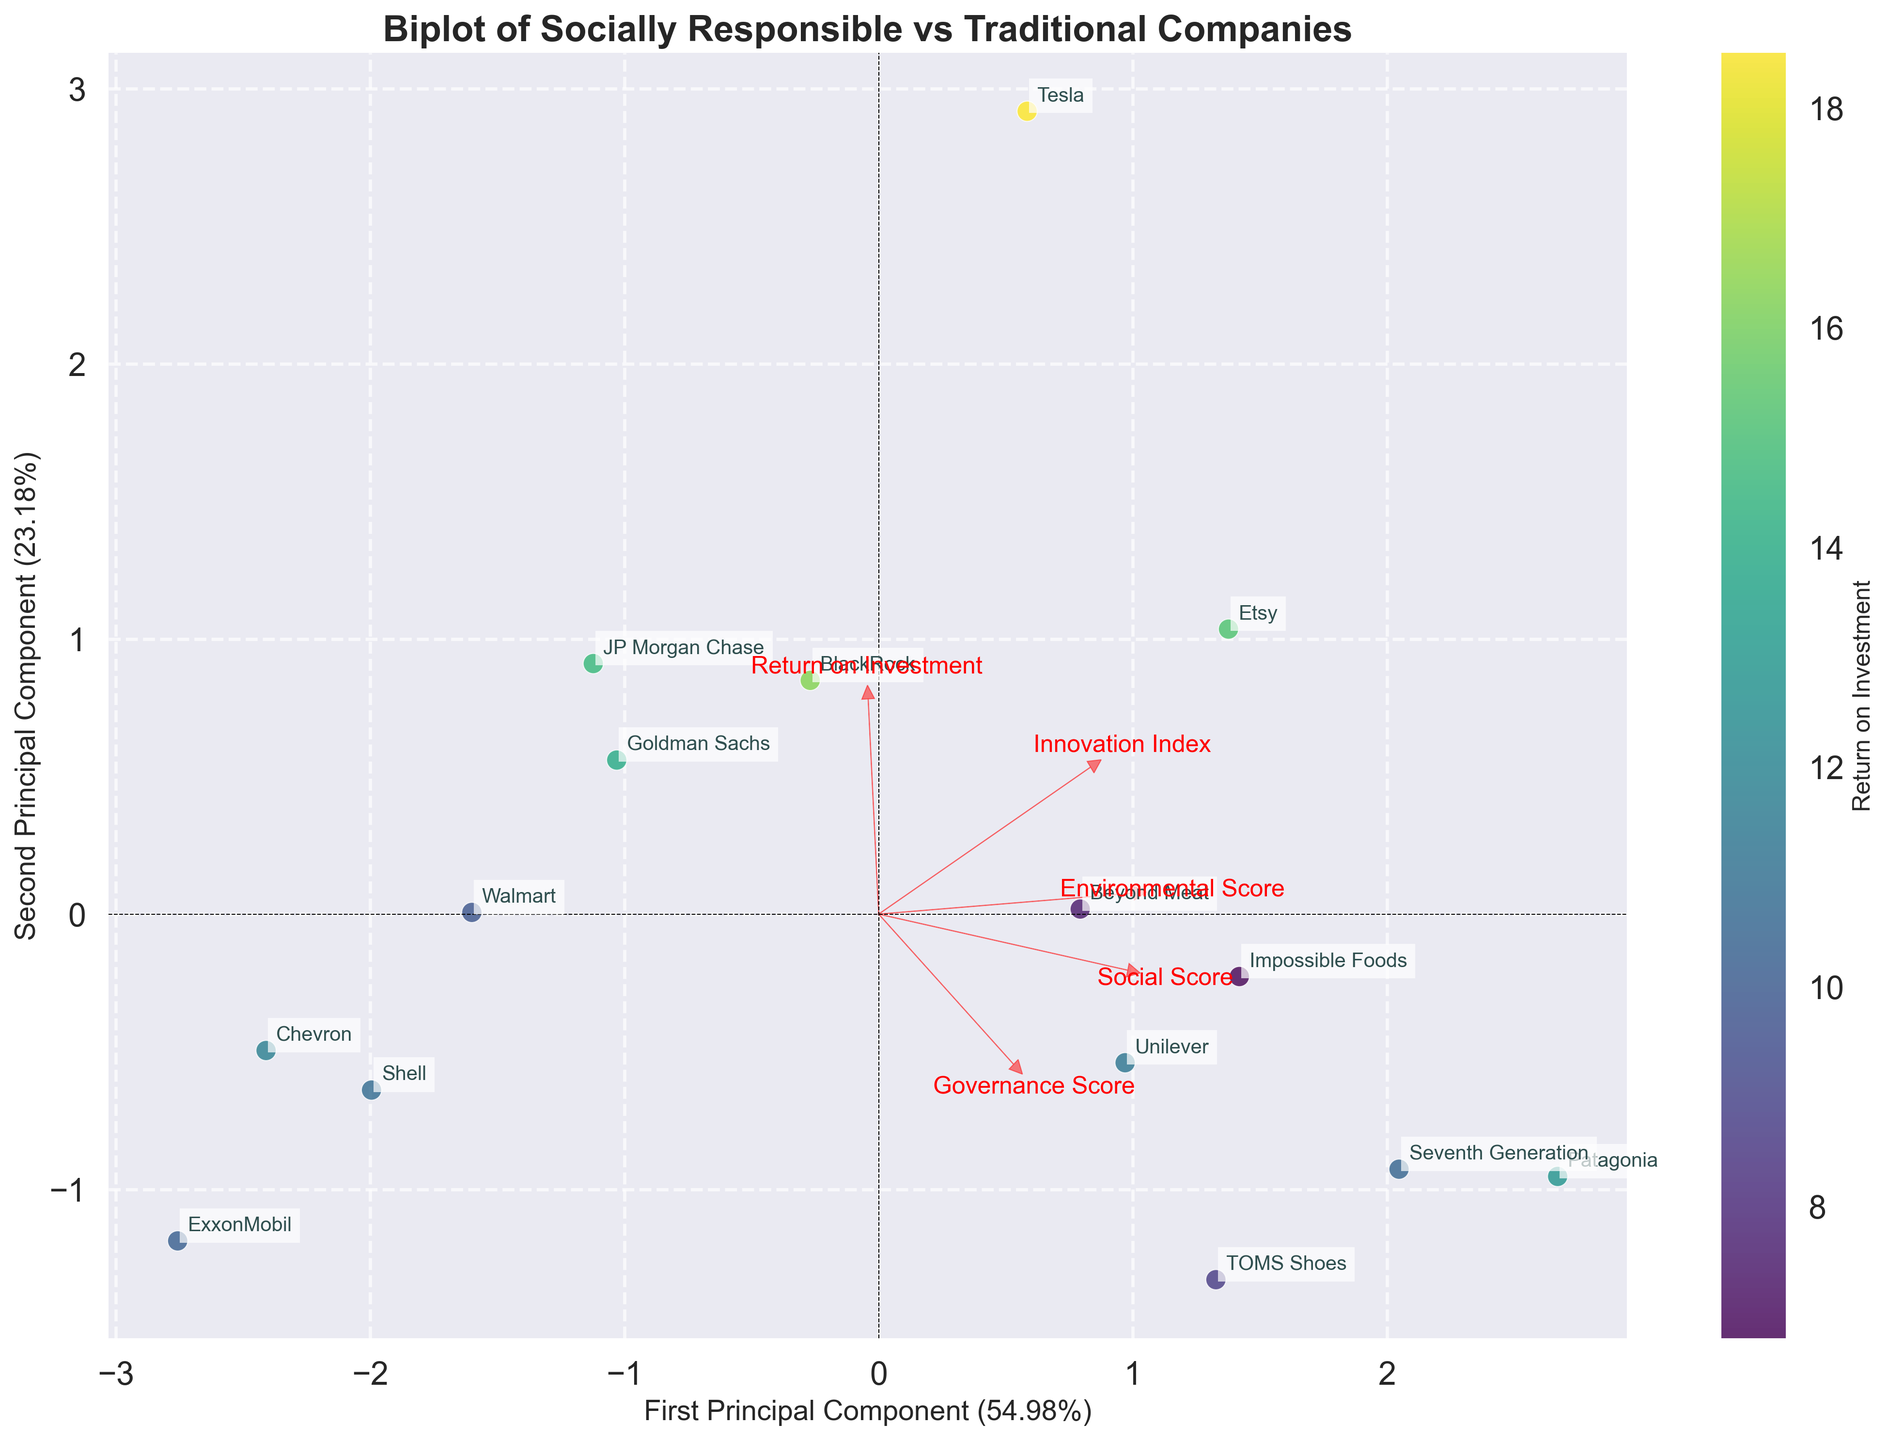How many companies are represented in the biplot? The biplot annotates each company name next to its corresponding data point. Counting these annotated names gives the total number of companies.
Answer: 15 Which company has the highest Return on Investment (ROI) according to the color scale? The color scale represents the ROI, with the brightest color indicating the highest ROI. Tesla’s data point appears the brightest according to the color map.
Answer: Tesla How much variance do the first and second principal components explain combined? The x-axis and y-axis labels indicate the variance explained. Summing the two percentages gives the total explained variance. The x-axis explains 37.28%, and the y-axis 24.73%. So, the total is 37.28% + 24.73%.
Answer: 62.01% What does the direction of the 'Environmental Score' loading vector indicate? The loading vectors show the direction and strength of each feature's contribution. The 'Environmental Score' vector pointing towards the top right implies positive contributions to both principal components.
Answer: Positive contribution to both components Which companies are closely located to Patagonia on the biplot? By examining the plot, the companies closest in PCA space to Patagonia, which is at the upper right, are identified.
Answer: Beyond Meat, Unilever Is there a noticeable difference in distribution between socially responsible and traditional companies? By comparing the spread and clustering of the companies known to be socially responsible versus traditional, one can observe the differences in their PCA representation. Socially responsible companies tend to cluster together in certain areas, indicating common feature strengths.
Answer: Yes, socially responsible clusters Do companies with high 'Innovation Index' scores also have high 'Return on Investment'? High 'Innovation Index' scores can be inferred from the proximity to the vector arrow on the plot, while ROI is indicated by the color shade. Companies such as Tesla, Etsy, and Impossible Foods show this trend.
Answer: Often, but not always Which feature contributes the most to the first principal component? The length and direction of the loading vectors relative to the first principal component identify the contributing feature with the largest magnitude. The 'Return on Investment' vector is longest along the x-axis.
Answer: Return on Investment How does ExxonMobil’s placement inform us about its features? ExxonMobil’s specific location relative to the origin and the other vectors like 'Environmental Score' and 'Innovation Index' suggests low values on these features.
Answer: Low Environmental and Innovation scores 